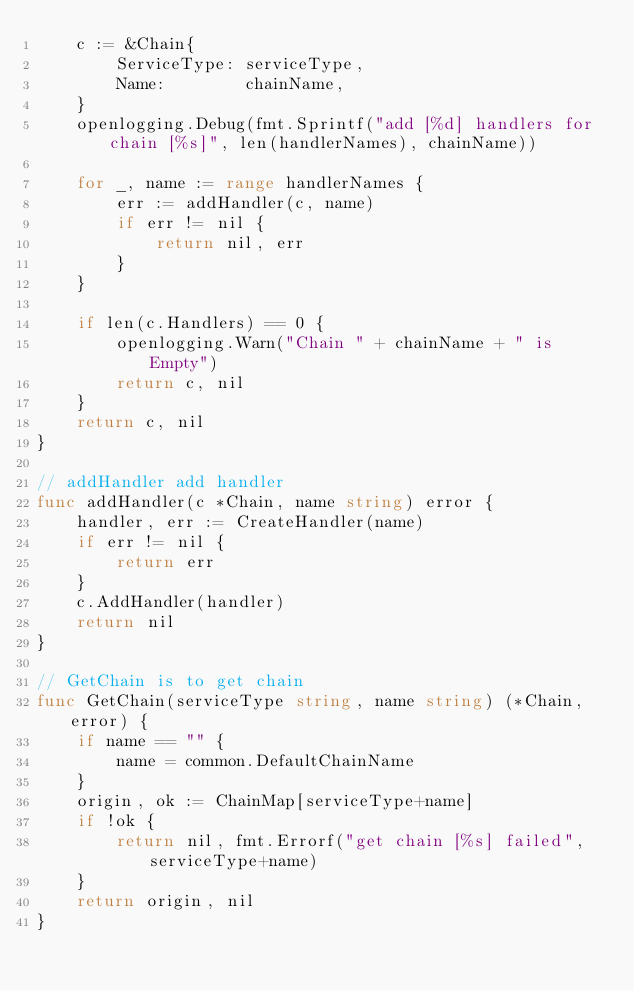Convert code to text. <code><loc_0><loc_0><loc_500><loc_500><_Go_>	c := &Chain{
		ServiceType: serviceType,
		Name:        chainName,
	}
	openlogging.Debug(fmt.Sprintf("add [%d] handlers for chain [%s]", len(handlerNames), chainName))

	for _, name := range handlerNames {
		err := addHandler(c, name)
		if err != nil {
			return nil, err
		}
	}

	if len(c.Handlers) == 0 {
		openlogging.Warn("Chain " + chainName + " is Empty")
		return c, nil
	}
	return c, nil
}

// addHandler add handler
func addHandler(c *Chain, name string) error {
	handler, err := CreateHandler(name)
	if err != nil {
		return err
	}
	c.AddHandler(handler)
	return nil
}

// GetChain is to get chain
func GetChain(serviceType string, name string) (*Chain, error) {
	if name == "" {
		name = common.DefaultChainName
	}
	origin, ok := ChainMap[serviceType+name]
	if !ok {
		return nil, fmt.Errorf("get chain [%s] failed", serviceType+name)
	}
	return origin, nil
}
</code> 